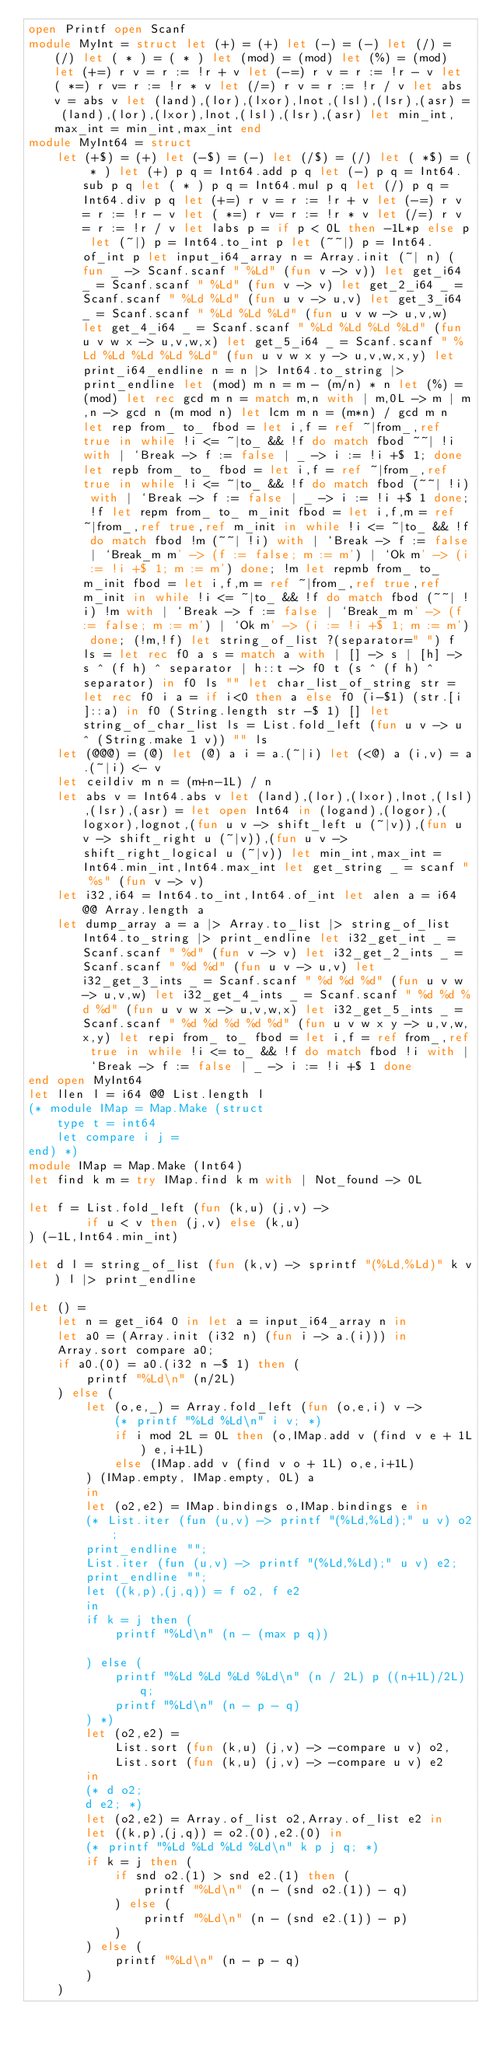<code> <loc_0><loc_0><loc_500><loc_500><_OCaml_>open Printf open Scanf
module MyInt = struct let (+) = (+) let (-) = (-) let (/) = (/) let ( * ) = ( * ) let (mod) = (mod) let (%) = (mod) let (+=) r v = r := !r + v let (-=) r v = r := !r - v let ( *=) r v= r := !r * v let (/=) r v = r := !r / v let abs v = abs v let (land),(lor),(lxor),lnot,(lsl),(lsr),(asr) = (land),(lor),(lxor),lnot,(lsl),(lsr),(asr) let min_int,max_int = min_int,max_int end
module MyInt64 = struct
	let (+$) = (+) let (-$) = (-) let (/$) = (/) let ( *$) = ( * ) let (+) p q = Int64.add p q let (-) p q = Int64.sub p q let ( * ) p q = Int64.mul p q let (/) p q = Int64.div p q let (+=) r v = r := !r + v let (-=) r v = r := !r - v let ( *=) r v= r := !r * v let (/=) r v = r := !r / v let labs p = if p < 0L then -1L*p else p let (~|) p = Int64.to_int p let (~~|) p = Int64.of_int p let input_i64_array n = Array.init (~| n) (fun _ -> Scanf.scanf " %Ld" (fun v -> v)) let get_i64 _ = Scanf.scanf " %Ld" (fun v -> v) let get_2_i64 _ = Scanf.scanf " %Ld %Ld" (fun u v -> u,v) let get_3_i64 _ = Scanf.scanf " %Ld %Ld %Ld" (fun u v w -> u,v,w) let get_4_i64 _ = Scanf.scanf " %Ld %Ld %Ld %Ld" (fun u v w x -> u,v,w,x) let get_5_i64 _ = Scanf.scanf " %Ld %Ld %Ld %Ld %Ld" (fun u v w x y -> u,v,w,x,y) let print_i64_endline n = n |> Int64.to_string |> print_endline let (mod) m n = m - (m/n) * n let (%) = (mod) let rec gcd m n = match m,n with | m,0L -> m | m,n -> gcd n (m mod n) let lcm m n = (m*n) / gcd m n let rep from_ to_ fbod = let i,f = ref ~|from_,ref true in while !i <= ~|to_ && !f do match fbod ~~| !i with | `Break -> f := false | _ -> i := !i +$ 1; done let repb from_ to_ fbod = let i,f = ref ~|from_,ref true in while !i <= ~|to_ && !f do match fbod (~~| !i) with | `Break -> f := false | _ -> i := !i +$ 1 done; !f let repm from_ to_ m_init fbod = let i,f,m = ref ~|from_,ref true,ref m_init in while !i <= ~|to_ && !f do match fbod !m (~~| !i) with | `Break -> f := false | `Break_m m' -> (f := false; m := m') | `Ok m' -> (i := !i +$ 1; m := m') done; !m let repmb from_ to_ m_init fbod = let i,f,m = ref ~|from_,ref true,ref m_init in while !i <= ~|to_ && !f do match fbod (~~| !i) !m with | `Break -> f := false | `Break_m m' -> (f := false; m := m') | `Ok m' -> (i := !i +$ 1; m := m') done; (!m,!f) let string_of_list ?(separator=" ") f ls = let rec f0 a s = match a with | [] -> s | [h] -> s ^ (f h) ^ separator | h::t -> f0 t (s ^ (f h) ^ separator) in f0 ls "" let char_list_of_string str = let rec f0 i a = if i<0 then a else f0 (i-$1) (str.[i]::a) in f0 (String.length str -$ 1) [] let string_of_char_list ls = List.fold_left (fun u v -> u ^ (String.make 1 v)) "" ls
	let (@@@) = (@) let (@) a i = a.(~|i) let (<@) a (i,v) = a.(~|i) <- v
	let ceildiv m n = (m+n-1L) / n
	let abs v = Int64.abs v let (land),(lor),(lxor),lnot,(lsl),(lsr),(asr) = let open Int64 in (logand),(logor),(logxor),lognot,(fun u v -> shift_left u (~|v)),(fun u v -> shift_right u (~|v)),(fun u v -> shift_right_logical u (~|v)) let min_int,max_int = Int64.min_int,Int64.max_int let get_string _ = scanf " %s" (fun v -> v)
	let i32,i64 = Int64.to_int,Int64.of_int let alen a = i64 @@ Array.length a
	let dump_array a = a |> Array.to_list |> string_of_list Int64.to_string |> print_endline let i32_get_int _ = Scanf.scanf " %d" (fun v -> v) let i32_get_2_ints _ = Scanf.scanf " %d %d" (fun u v -> u,v) let i32_get_3_ints _ = Scanf.scanf " %d %d %d" (fun u v w -> u,v,w) let i32_get_4_ints _ = Scanf.scanf " %d %d %d %d" (fun u v w x -> u,v,w,x) let i32_get_5_ints _ = Scanf.scanf " %d %d %d %d %d" (fun u v w x y -> u,v,w,x,y) let repi from_ to_ fbod = let i,f = ref from_,ref true in while !i <= to_ && !f do match fbod !i with | `Break -> f := false | _ -> i := !i +$ 1 done
end open MyInt64
let llen l = i64 @@ List.length l
(* module IMap = Map.Make (struct
	type t = int64
	let compare i j = 
end) *)
module IMap = Map.Make (Int64)
let find k m = try IMap.find k m with | Not_found -> 0L

let f = List.fold_left (fun (k,u) (j,v) -> 
		if u < v then (j,v) else (k,u)
) (-1L,Int64.min_int)

let d l = string_of_list (fun (k,v) -> sprintf "(%Ld,%Ld)" k v) l |> print_endline

let () =
	let n = get_i64 0 in let a = input_i64_array n in
	let a0 = (Array.init (i32 n) (fun i -> a.(i))) in
	Array.sort compare a0;
	if a0.(0) = a0.(i32 n -$ 1) then (
		printf "%Ld\n" (n/2L)
	) else (
		let (o,e,_) = Array.fold_left (fun (o,e,i) v ->
			(* printf "%Ld %Ld\n" i v; *)
			if i mod 2L = 0L then (o,IMap.add v (find v e + 1L) e,i+1L)
			else (IMap.add v (find v o + 1L) o,e,i+1L)
		) (IMap.empty, IMap.empty, 0L) a
		in
		let (o2,e2) = IMap.bindings o,IMap.bindings e in
		(* List.iter (fun (u,v) -> printf "(%Ld,%Ld);" u v) o2;
		print_endline "";
		List.iter (fun (u,v) -> printf "(%Ld,%Ld);" u v) e2;
		print_endline "";
		let ((k,p),(j,q)) = f o2, f e2
		in
		if k = j then (
			printf "%Ld\n" (n - (max p q))

		) else (
			printf "%Ld %Ld %Ld %Ld\n" (n / 2L) p ((n+1L)/2L) q;
			printf "%Ld\n" (n - p - q)
		) *)
		let (o2,e2) =
			List.sort (fun (k,u) (j,v) -> -compare u v) o2,
			List.sort (fun (k,u) (j,v) -> -compare u v) e2
		in
		(* d o2;
		d e2; *)
		let (o2,e2) = Array.of_list o2,Array.of_list e2 in
		let ((k,p),(j,q)) = o2.(0),e2.(0) in
		(* printf "%Ld %Ld %Ld %Ld\n" k p j q; *)
		if k = j then (
			if snd o2.(1) > snd e2.(1) then (
				printf "%Ld\n" (n - (snd o2.(1)) - q)
			) else (
				printf "%Ld\n" (n - (snd e2.(1)) - p)
			)
		) else (
			printf "%Ld\n" (n - p - q)
		)
	)







</code> 